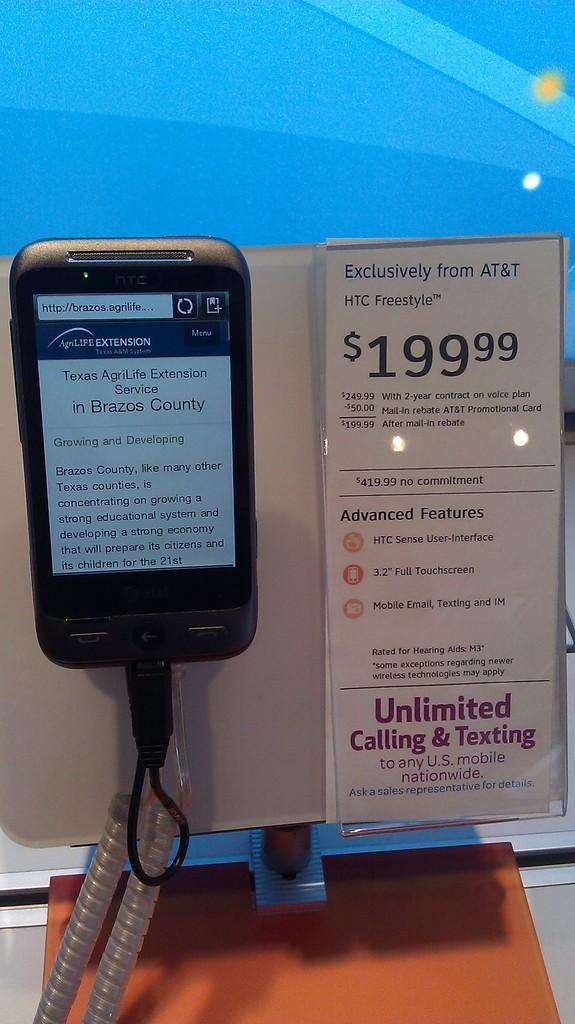<image>
Describe the image concisely. an HTC Freestyle cell phone with an Exclusive plan from AT&T 